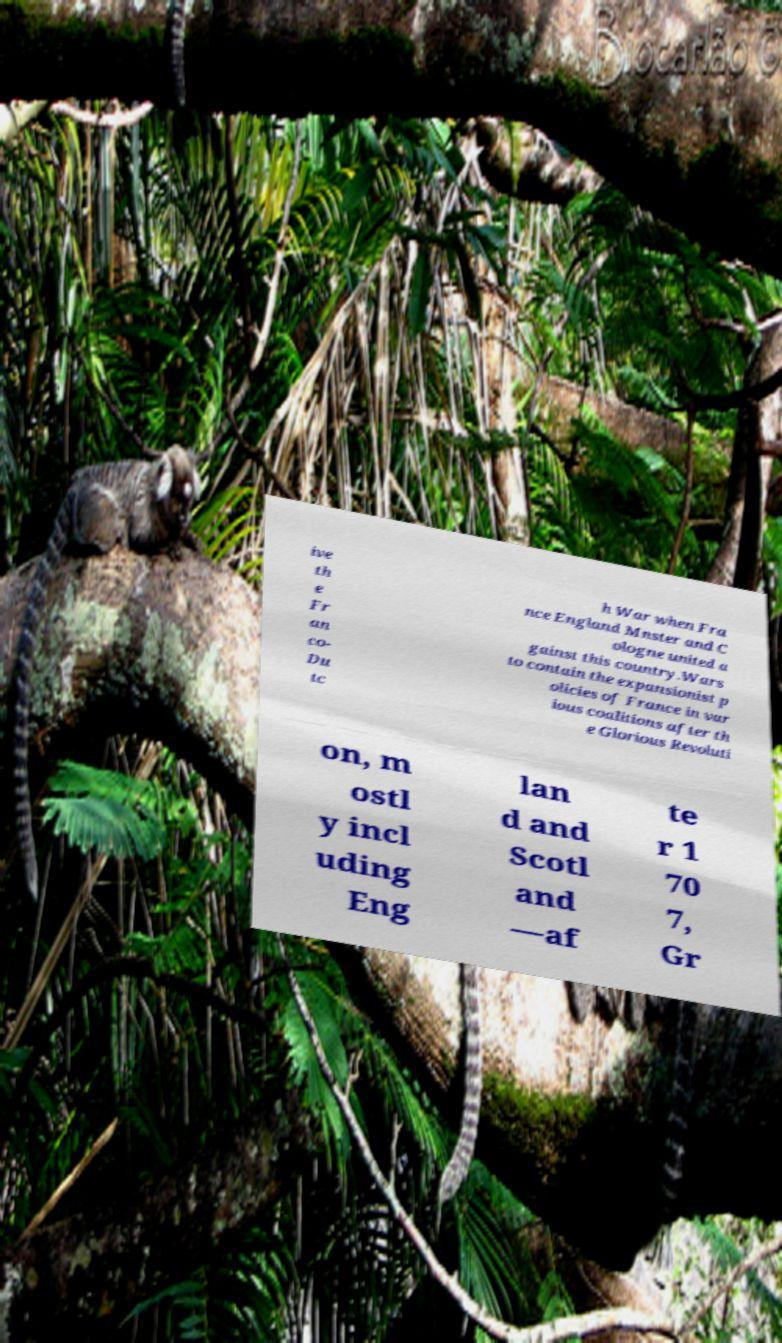Can you read and provide the text displayed in the image?This photo seems to have some interesting text. Can you extract and type it out for me? ive th e Fr an co- Du tc h War when Fra nce England Mnster and C ologne united a gainst this country.Wars to contain the expansionist p olicies of France in var ious coalitions after th e Glorious Revoluti on, m ostl y incl uding Eng lan d and Scotl and —af te r 1 70 7, Gr 